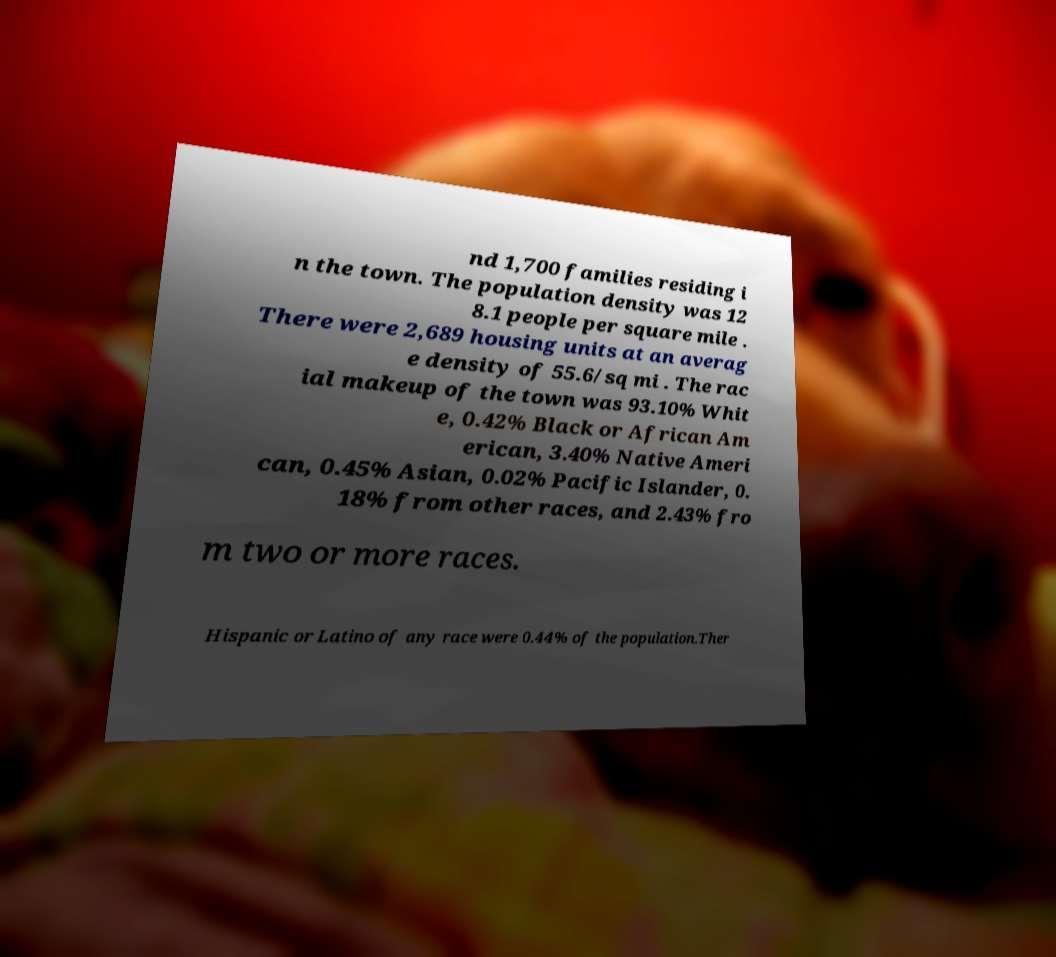Please identify and transcribe the text found in this image. nd 1,700 families residing i n the town. The population density was 12 8.1 people per square mile . There were 2,689 housing units at an averag e density of 55.6/sq mi . The rac ial makeup of the town was 93.10% Whit e, 0.42% Black or African Am erican, 3.40% Native Ameri can, 0.45% Asian, 0.02% Pacific Islander, 0. 18% from other races, and 2.43% fro m two or more races. Hispanic or Latino of any race were 0.44% of the population.Ther 